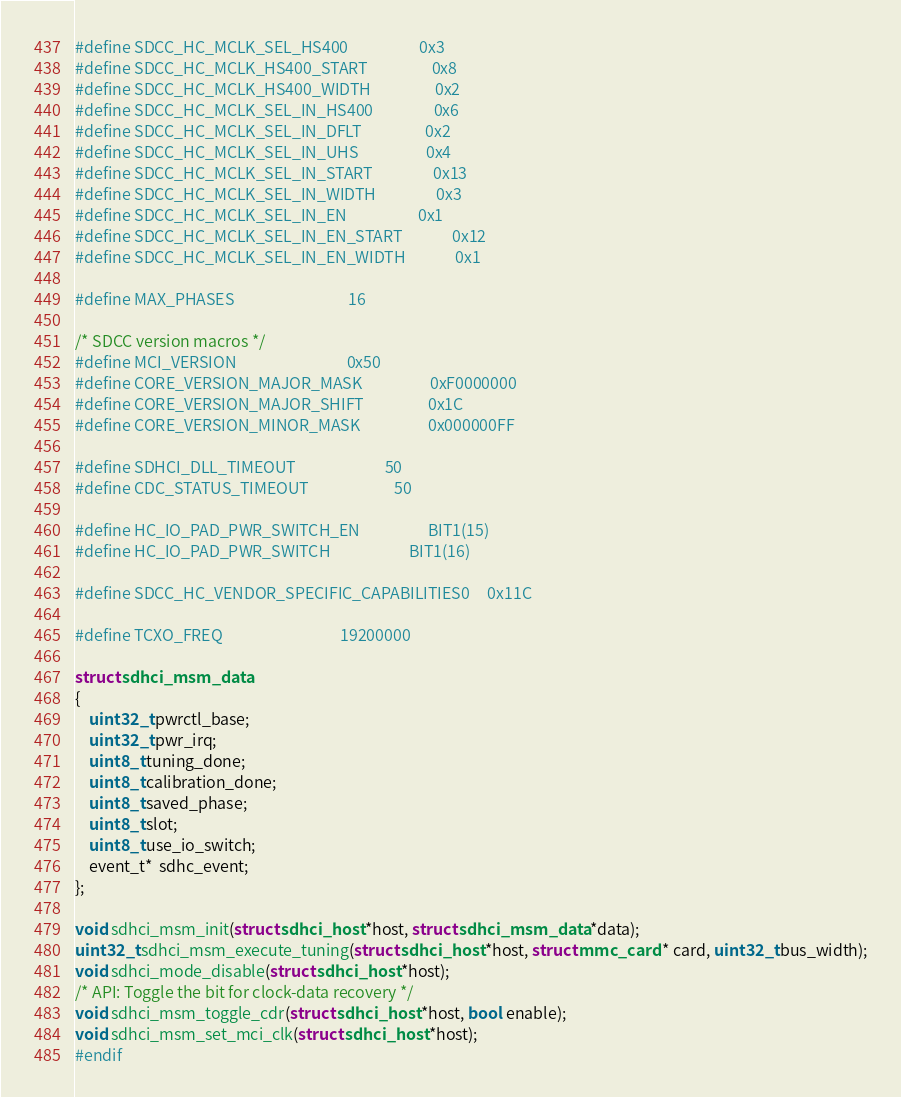<code> <loc_0><loc_0><loc_500><loc_500><_C_>#define SDCC_HC_MCLK_SEL_HS400                    0x3
#define SDCC_HC_MCLK_HS400_START                  0x8
#define SDCC_HC_MCLK_HS400_WIDTH                  0x2
#define SDCC_HC_MCLK_SEL_IN_HS400                 0x6
#define SDCC_HC_MCLK_SEL_IN_DFLT                  0x2
#define SDCC_HC_MCLK_SEL_IN_UHS                   0x4
#define SDCC_HC_MCLK_SEL_IN_START                 0x13
#define SDCC_HC_MCLK_SEL_IN_WIDTH                 0x3
#define SDCC_HC_MCLK_SEL_IN_EN                    0x1
#define SDCC_HC_MCLK_SEL_IN_EN_START              0x12
#define SDCC_HC_MCLK_SEL_IN_EN_WIDTH              0x1

#define MAX_PHASES                                16

/* SDCC version macros */
#define MCI_VERSION                               0x50
#define CORE_VERSION_MAJOR_MASK                   0xF0000000
#define CORE_VERSION_MAJOR_SHIFT                  0x1C
#define CORE_VERSION_MINOR_MASK                   0x000000FF

#define SDHCI_DLL_TIMEOUT                         50
#define CDC_STATUS_TIMEOUT                        50

#define HC_IO_PAD_PWR_SWITCH_EN                   BIT1(15)
#define HC_IO_PAD_PWR_SWITCH                      BIT1(16)

#define SDCC_HC_VENDOR_SPECIFIC_CAPABILITIES0     0x11C

#define TCXO_FREQ                                 19200000

struct sdhci_msm_data
{
	uint32_t pwrctl_base;
	uint32_t pwr_irq;
	uint8_t tuning_done;
	uint8_t calibration_done;
	uint8_t saved_phase;
	uint8_t slot;
	uint8_t use_io_switch;
	event_t*  sdhc_event;
};

void sdhci_msm_init(struct sdhci_host *host, struct sdhci_msm_data *data);
uint32_t sdhci_msm_execute_tuning(struct sdhci_host *host, struct mmc_card * card, uint32_t bus_width);
void sdhci_mode_disable(struct sdhci_host *host);
/* API: Toggle the bit for clock-data recovery */
void sdhci_msm_toggle_cdr(struct sdhci_host *host, bool enable);
void sdhci_msm_set_mci_clk(struct sdhci_host *host);
#endif
</code> 